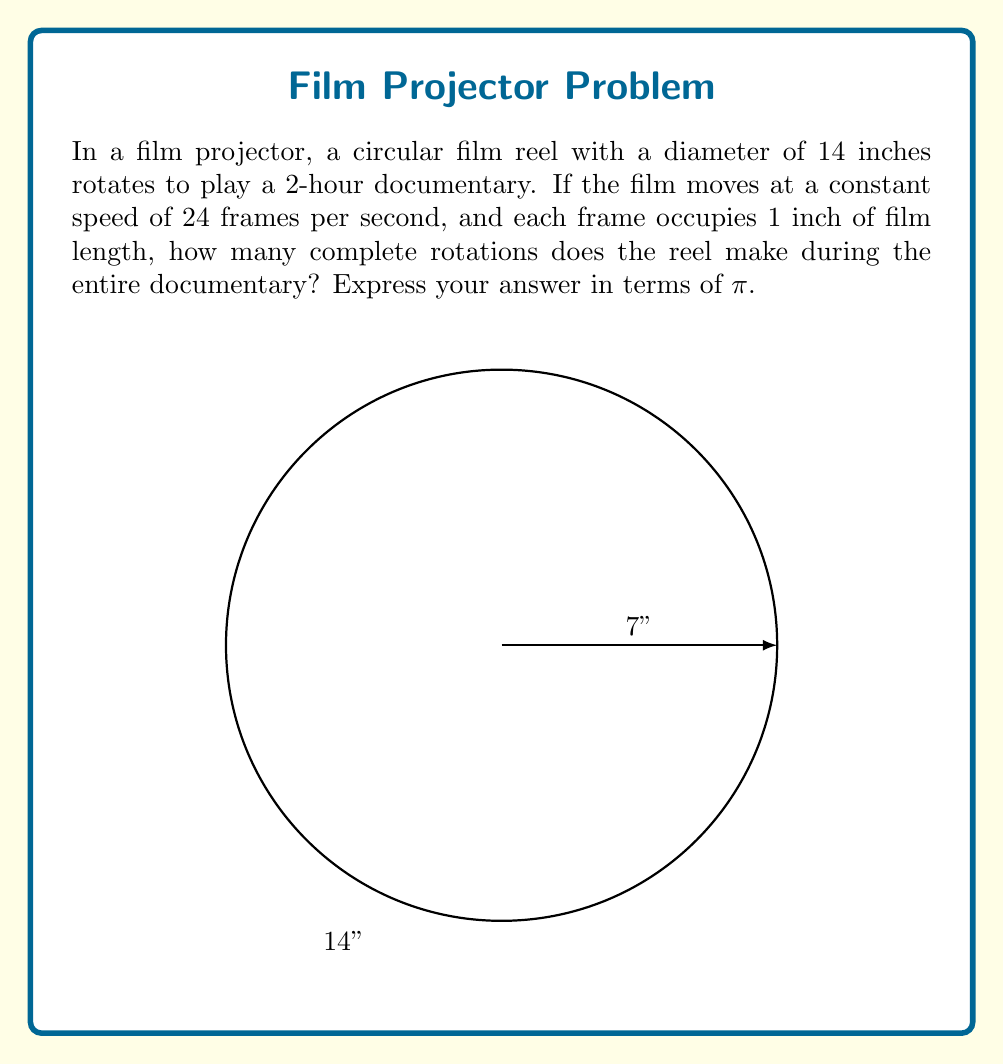Can you solve this math problem? Let's approach this step-by-step:

1) First, we need to calculate the total length of the film:
   - Duration of the documentary = 2 hours = 2 × 60 × 60 = 7200 seconds
   - Frames per second = 24
   - Total number of frames = 7200 × 24 = 172,800 frames
   - Each frame occupies 1 inch
   - Total length of film = 172,800 inches

2) Now, we need to find the circumference of the reel:
   - Diameter = 14 inches
   - Circumference = π × diameter = 14π inches

3) The number of rotations is the total length divided by the circumference:
   $$ \text{Number of rotations} = \frac{\text{Total length}}{\text{Circumference}} = \frac{172,800}{14\pi} $$

4) Simplify the fraction:
   $$ \frac{172,800}{14\pi} = \frac{12,343}{\pi} $$

Therefore, the reel makes $\frac{12,343}{\pi}$ complete rotations during the entire documentary.
Answer: $\frac{12,343}{\pi}$ 